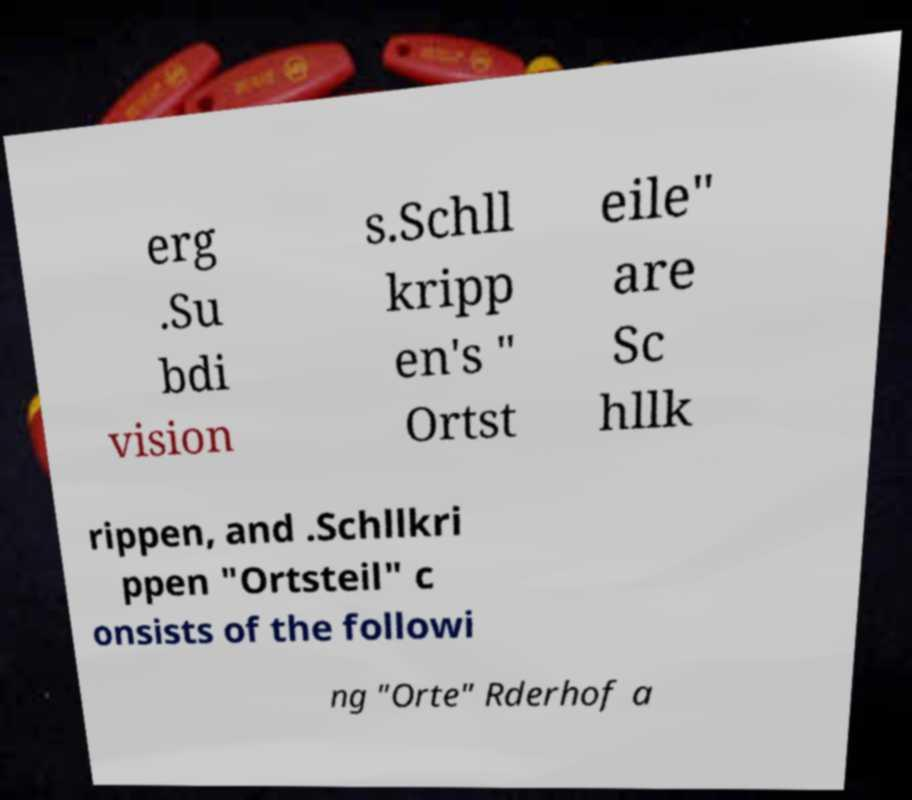Can you accurately transcribe the text from the provided image for me? erg .Su bdi vision s.Schll kripp en's " Ortst eile" are Sc hllk rippen, and .Schllkri ppen "Ortsteil" c onsists of the followi ng "Orte" Rderhof a 